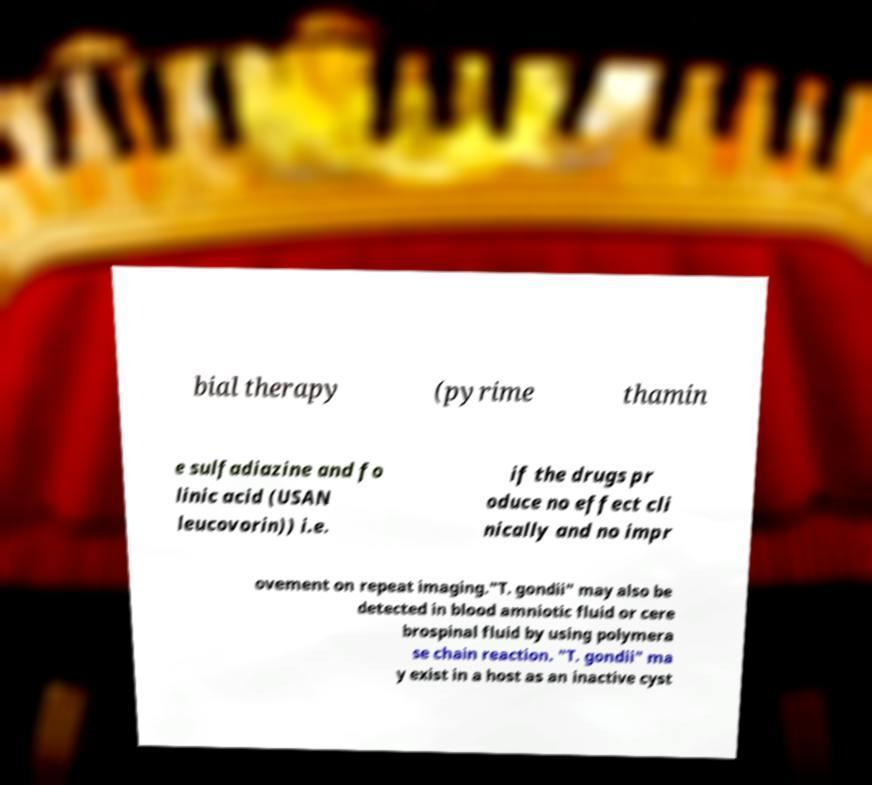Can you read and provide the text displayed in the image?This photo seems to have some interesting text. Can you extract and type it out for me? bial therapy (pyrime thamin e sulfadiazine and fo linic acid (USAN leucovorin)) i.e. if the drugs pr oduce no effect cli nically and no impr ovement on repeat imaging."T. gondii" may also be detected in blood amniotic fluid or cere brospinal fluid by using polymera se chain reaction. "T. gondii" ma y exist in a host as an inactive cyst 